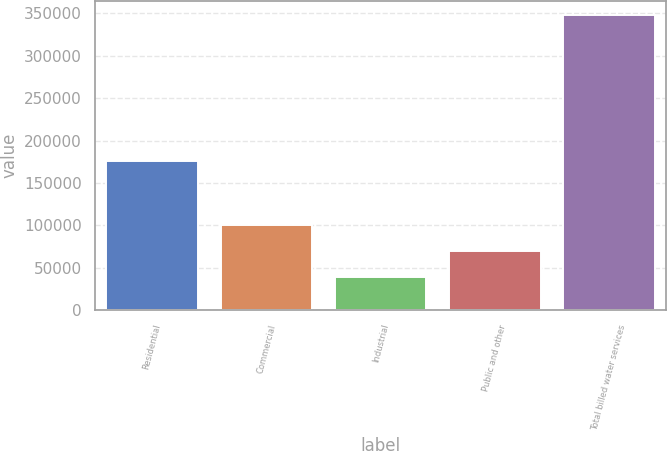<chart> <loc_0><loc_0><loc_500><loc_500><bar_chart><fcel>Residential<fcel>Commercial<fcel>Industrial<fcel>Public and other<fcel>Total billed water services<nl><fcel>175653<fcel>100741<fcel>38991<fcel>69865.9<fcel>347740<nl></chart> 